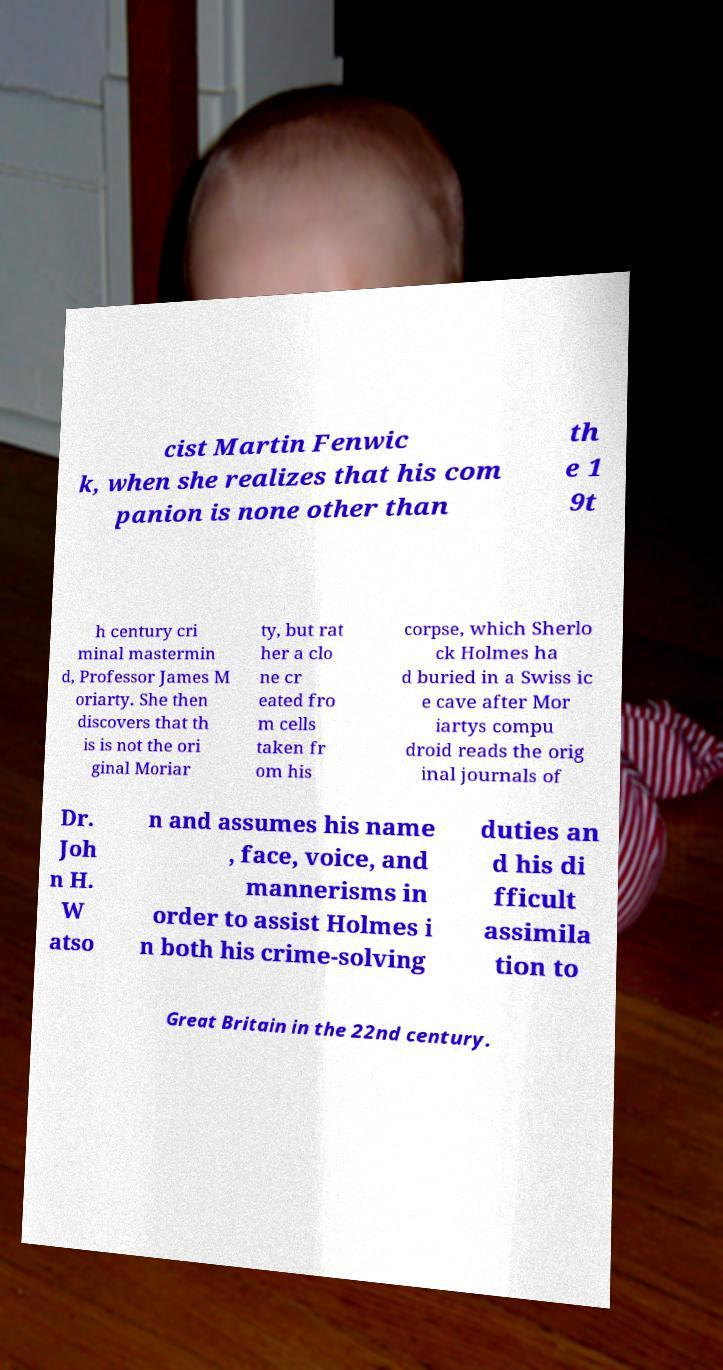Please identify and transcribe the text found in this image. cist Martin Fenwic k, when she realizes that his com panion is none other than th e 1 9t h century cri minal mastermin d, Professor James M oriarty. She then discovers that th is is not the ori ginal Moriar ty, but rat her a clo ne cr eated fro m cells taken fr om his corpse, which Sherlo ck Holmes ha d buried in a Swiss ic e cave after Mor iartys compu droid reads the orig inal journals of Dr. Joh n H. W atso n and assumes his name , face, voice, and mannerisms in order to assist Holmes i n both his crime-solving duties an d his di fficult assimila tion to Great Britain in the 22nd century. 